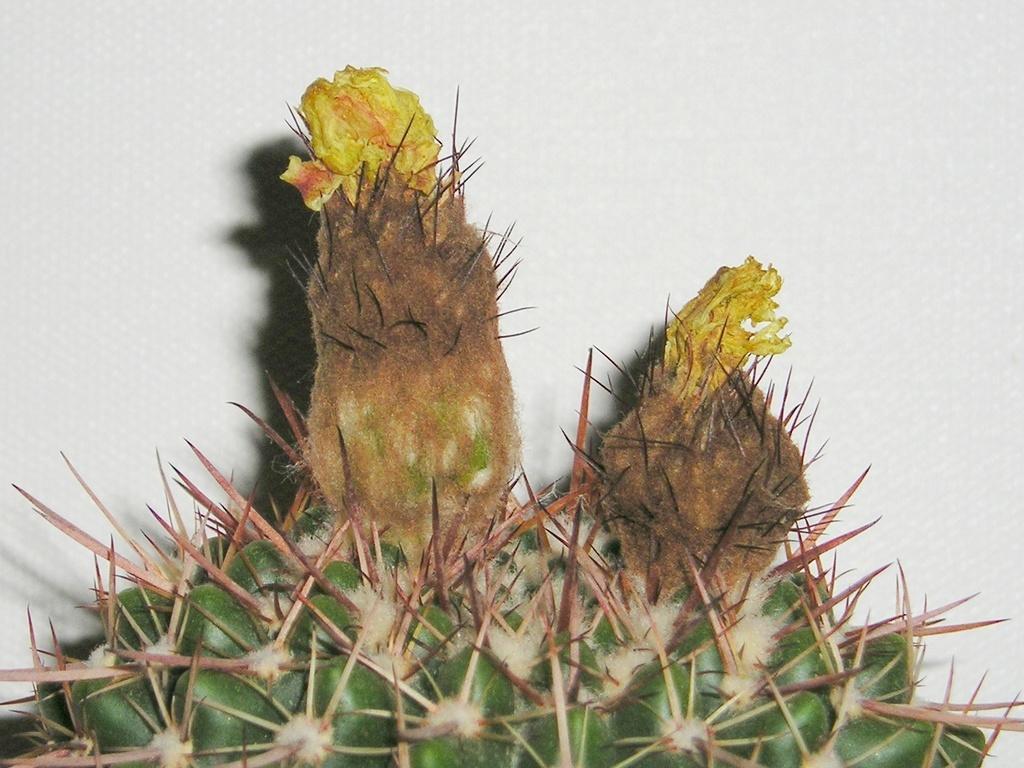Can you describe this image briefly? In this image I can see a cactus plant along with the flowers which are in yellow color. The background is in white color. 